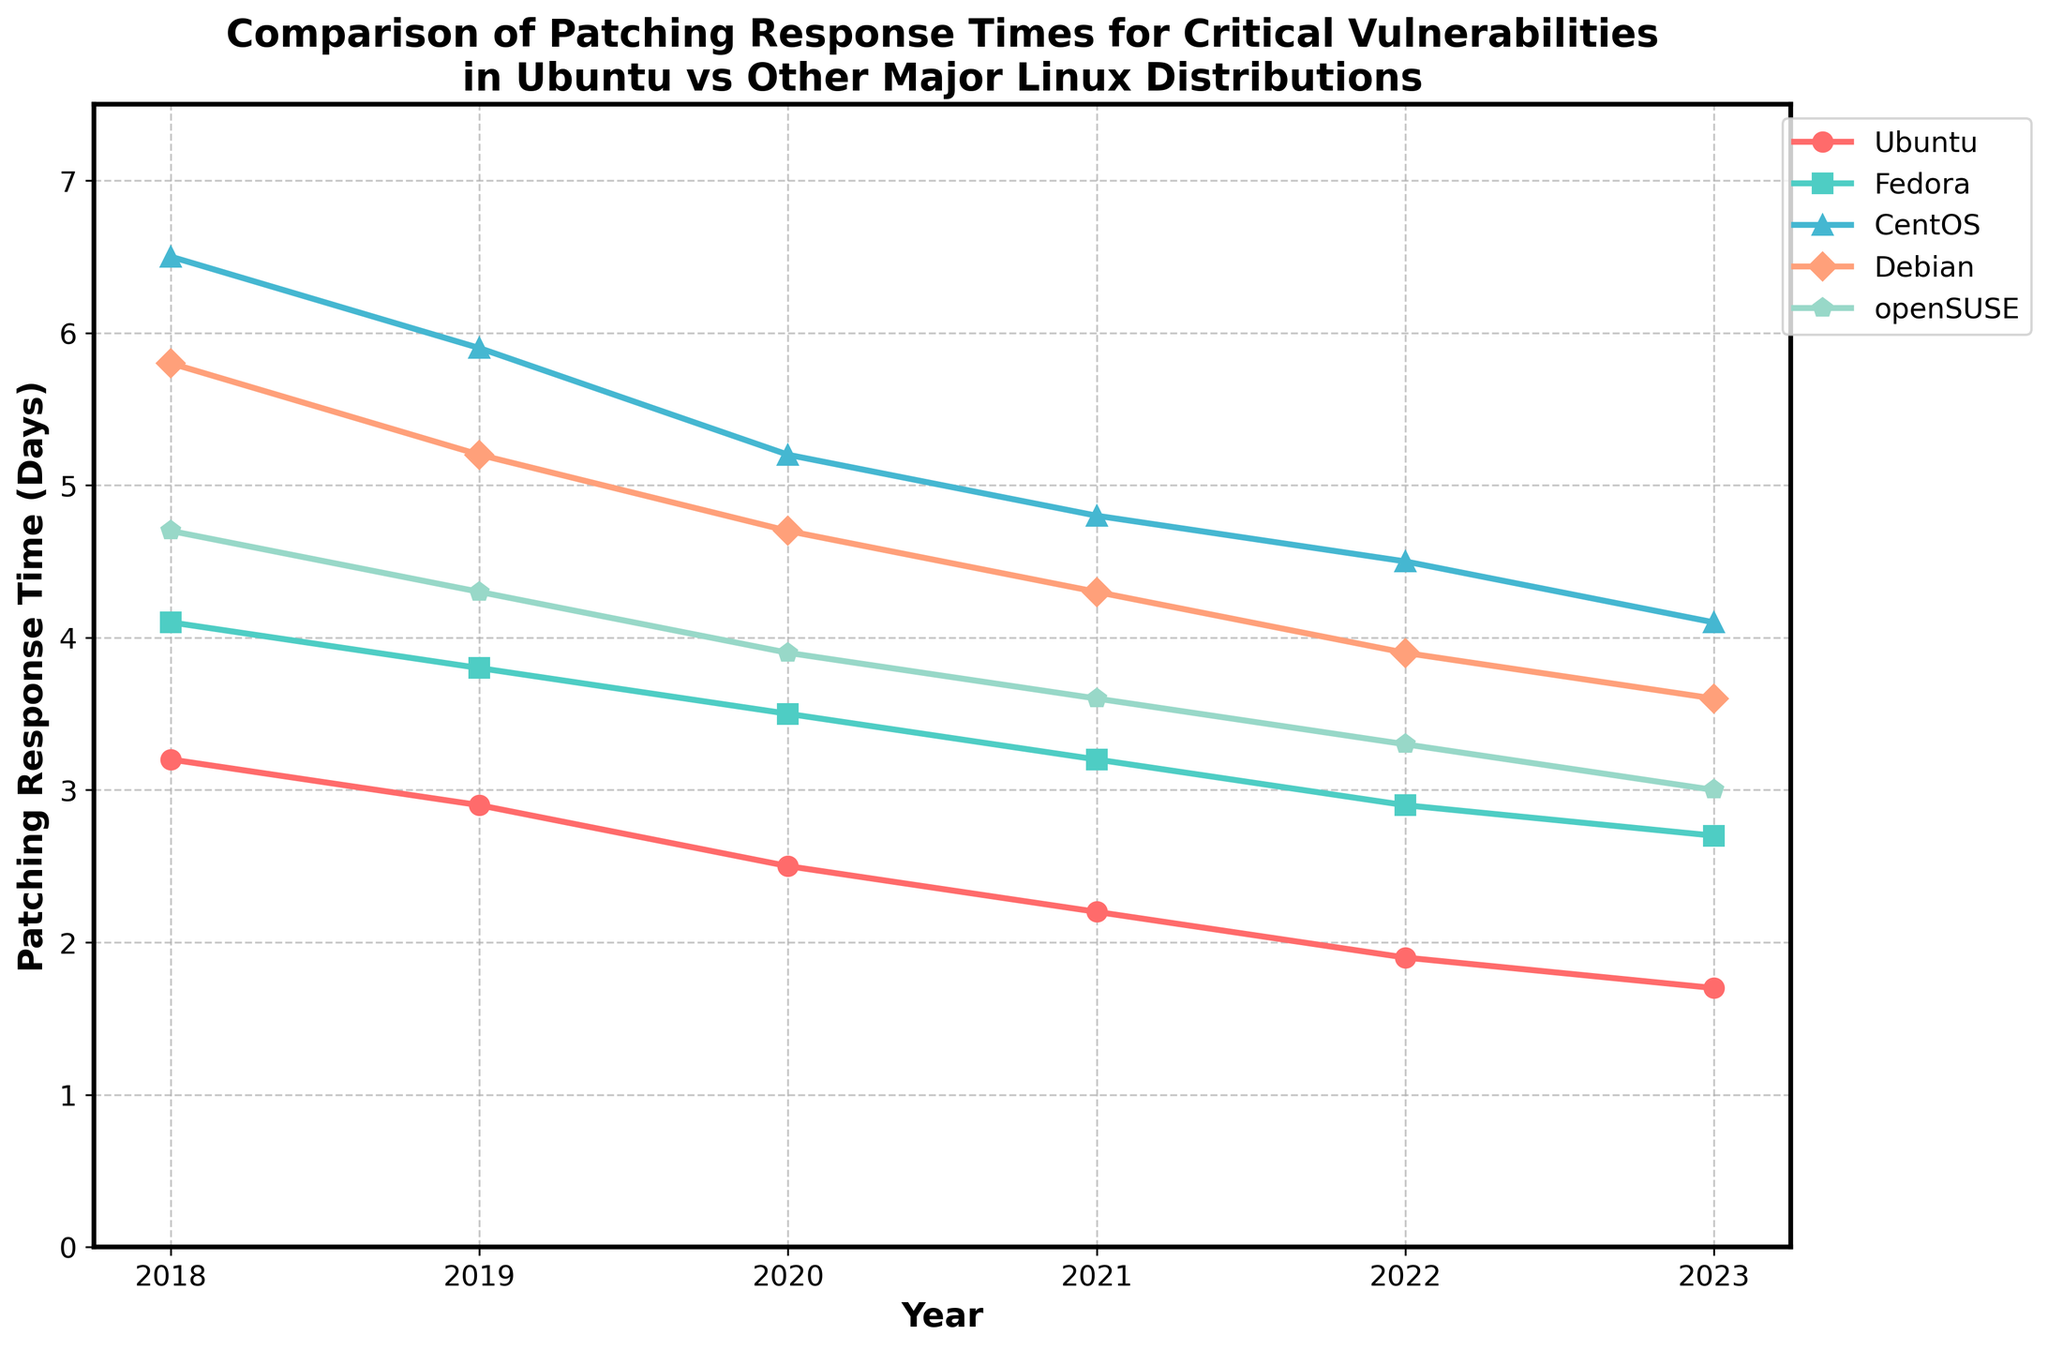what is the average patching response time for Ubuntu from 2018 to 2023? Add up the patching response times for Ubuntu from 2018 to 2023: 3.2 + 2.9 + 2.5 + 2.2 + 1.9 + 1.7 = 14.4, then divide by the number of years: 14.4 / 6 = 2.4
Answer: 2.4 Which Linux distribution had the quickest response time in 2023? Look at the response times for all distributions in 2023. Ubuntu has the lowest value, which is 1.7 days
Answer: Ubuntu Which year did Fedora have the same patching response time as Debian? Look for the year when both Fedora and Debian have the same response time. In 2023, both have different values; hence, there is no year with the same value
Answer: No specific year How much did CentOS's patching response time improve from 2018 to 2023? Subtract the value for CentOS in 2023 from the value in 2018: 6.5 - 4.1 = 2.4 days
Answer: 2.4 days By how many days did openSUSE's patching response time decrease from 2021 to 2023? Subtract openSUSE's value in 2023 from the value in 2021: 3.6 - 3.0 = 0.6 days
Answer: 0.6 days In which year did Ubuntu first achieve less than a 2-day patching response time? Check the years for when Ubuntu's value is less than 2. In 2022, Ubuntu's response time is 1.9
Answer: 2022 Which distribution had the greatest total decrease in response time from 2018 to 2023? Calculate the decrease for each distribution by subtracting the value in 2023 from the value in 2018. Ubuntu: 3.2-1.7, Fedora: 4.1-2.7, CentOS: 6.5-4.1, Debian: 5.8-3.6, openSUSE: 4.7-3.0. The highest difference is for Ubuntu with a decrease of 1.5
Answer: Ubuntu What is the total response time difference between Ubuntu and openSUSE in 2020? Subtract openSUSE's value from Ubuntu's in 2020: 2.5 - 3.9 = -1.4 (absolute difference is 1.4 days)
Answer: 1.4 days Did Fedora or Debian show more consistent improvement in response time from 2018 to 2023? Fedora improved by 4.1 - 2.7 = 1.4 days while Debian improved by 5.8 - 3.6 = 2.2 days. Since Fedora has lower values, it's more consistent
Answer: Fedora 